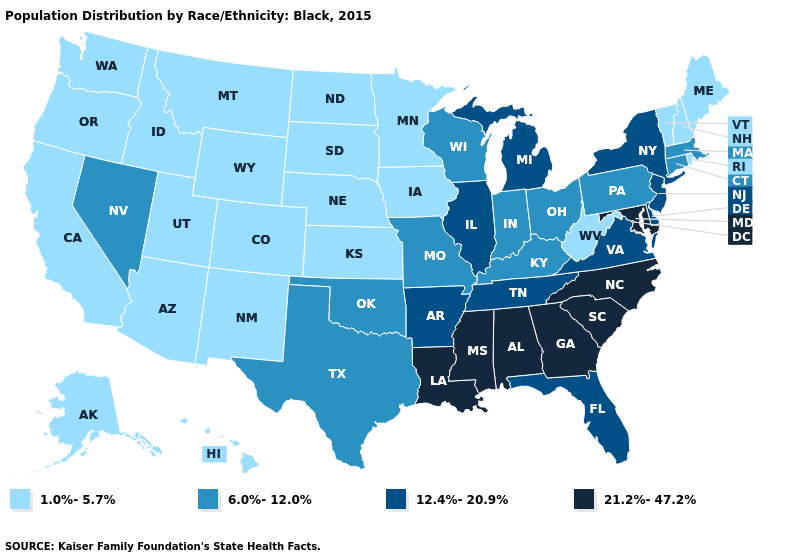Does Vermont have the lowest value in the USA?
Write a very short answer. Yes. Name the states that have a value in the range 12.4%-20.9%?
Answer briefly. Arkansas, Delaware, Florida, Illinois, Michigan, New Jersey, New York, Tennessee, Virginia. Name the states that have a value in the range 1.0%-5.7%?
Give a very brief answer. Alaska, Arizona, California, Colorado, Hawaii, Idaho, Iowa, Kansas, Maine, Minnesota, Montana, Nebraska, New Hampshire, New Mexico, North Dakota, Oregon, Rhode Island, South Dakota, Utah, Vermont, Washington, West Virginia, Wyoming. Among the states that border Indiana , does Kentucky have the lowest value?
Keep it brief. Yes. Name the states that have a value in the range 21.2%-47.2%?
Concise answer only. Alabama, Georgia, Louisiana, Maryland, Mississippi, North Carolina, South Carolina. Does Maryland have the lowest value in the USA?
Be succinct. No. Which states have the lowest value in the USA?
Keep it brief. Alaska, Arizona, California, Colorado, Hawaii, Idaho, Iowa, Kansas, Maine, Minnesota, Montana, Nebraska, New Hampshire, New Mexico, North Dakota, Oregon, Rhode Island, South Dakota, Utah, Vermont, Washington, West Virginia, Wyoming. What is the value of Michigan?
Be succinct. 12.4%-20.9%. Does New Hampshire have the lowest value in the Northeast?
Keep it brief. Yes. Among the states that border Oklahoma , which have the lowest value?
Keep it brief. Colorado, Kansas, New Mexico. Does Alabama have the highest value in the USA?
Write a very short answer. Yes. What is the value of Hawaii?
Concise answer only. 1.0%-5.7%. What is the value of Arizona?
Keep it brief. 1.0%-5.7%. Does Nevada have the highest value in the West?
Be succinct. Yes. What is the lowest value in the USA?
Answer briefly. 1.0%-5.7%. 